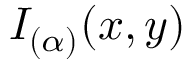<formula> <loc_0><loc_0><loc_500><loc_500>I _ { ( \alpha ) } ( x , y )</formula> 